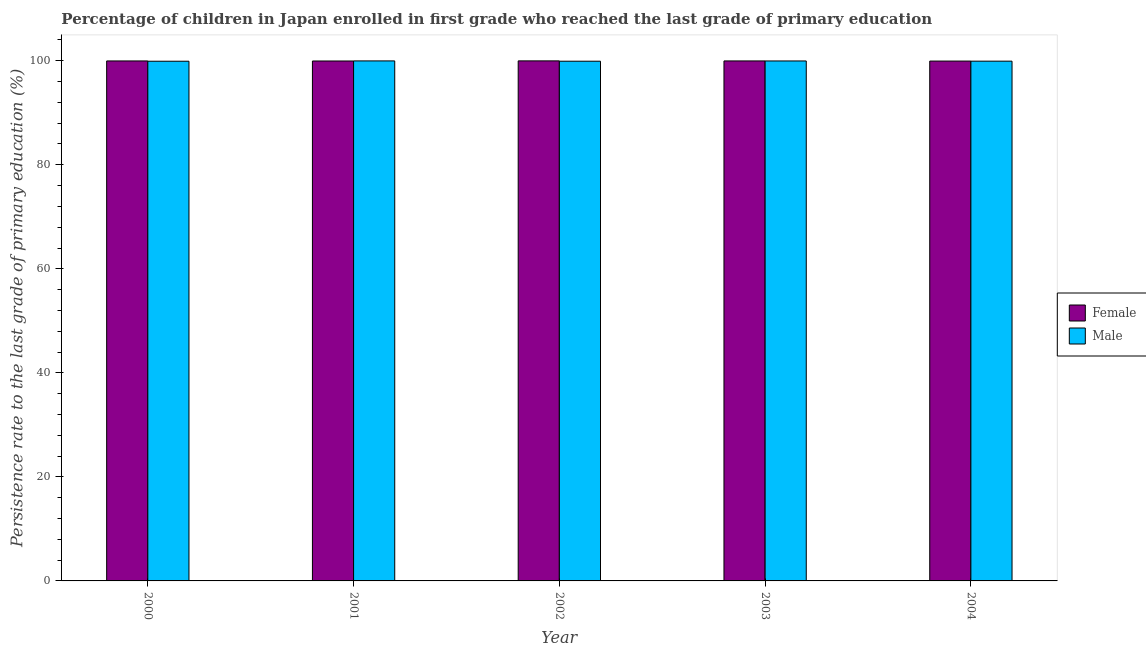How many different coloured bars are there?
Provide a short and direct response. 2. How many groups of bars are there?
Offer a very short reply. 5. Are the number of bars on each tick of the X-axis equal?
Your answer should be compact. Yes. How many bars are there on the 2nd tick from the left?
Keep it short and to the point. 2. What is the label of the 1st group of bars from the left?
Your answer should be very brief. 2000. What is the persistence rate of female students in 2002?
Keep it short and to the point. 99.98. Across all years, what is the maximum persistence rate of female students?
Your response must be concise. 99.98. Across all years, what is the minimum persistence rate of female students?
Ensure brevity in your answer.  99.94. In which year was the persistence rate of male students maximum?
Offer a terse response. 2001. In which year was the persistence rate of male students minimum?
Give a very brief answer. 2000. What is the total persistence rate of male students in the graph?
Give a very brief answer. 499.69. What is the difference between the persistence rate of female students in 2003 and that in 2004?
Ensure brevity in your answer.  0.03. What is the difference between the persistence rate of male students in 2000 and the persistence rate of female students in 2002?
Your answer should be very brief. -0. What is the average persistence rate of male students per year?
Your response must be concise. 99.94. What is the ratio of the persistence rate of male students in 2001 to that in 2004?
Your answer should be very brief. 1. Is the persistence rate of female students in 2000 less than that in 2004?
Offer a very short reply. No. Is the difference between the persistence rate of male students in 2000 and 2001 greater than the difference between the persistence rate of female students in 2000 and 2001?
Keep it short and to the point. No. What is the difference between the highest and the second highest persistence rate of male students?
Your response must be concise. 0.01. What is the difference between the highest and the lowest persistence rate of female students?
Offer a terse response. 0.04. In how many years, is the persistence rate of female students greater than the average persistence rate of female students taken over all years?
Offer a terse response. 3. Are all the bars in the graph horizontal?
Keep it short and to the point. No. Are the values on the major ticks of Y-axis written in scientific E-notation?
Keep it short and to the point. No. What is the title of the graph?
Give a very brief answer. Percentage of children in Japan enrolled in first grade who reached the last grade of primary education. Does "From Government" appear as one of the legend labels in the graph?
Your response must be concise. No. What is the label or title of the X-axis?
Give a very brief answer. Year. What is the label or title of the Y-axis?
Make the answer very short. Persistence rate to the last grade of primary education (%). What is the Persistence rate to the last grade of primary education (%) in Female in 2000?
Offer a terse response. 99.97. What is the Persistence rate to the last grade of primary education (%) in Male in 2000?
Your answer should be very brief. 99.91. What is the Persistence rate to the last grade of primary education (%) of Female in 2001?
Make the answer very short. 99.96. What is the Persistence rate to the last grade of primary education (%) in Male in 2001?
Your answer should be compact. 99.97. What is the Persistence rate to the last grade of primary education (%) of Female in 2002?
Offer a terse response. 99.98. What is the Persistence rate to the last grade of primary education (%) of Male in 2002?
Offer a terse response. 99.91. What is the Persistence rate to the last grade of primary education (%) of Female in 2003?
Offer a terse response. 99.97. What is the Persistence rate to the last grade of primary education (%) of Male in 2003?
Your response must be concise. 99.96. What is the Persistence rate to the last grade of primary education (%) in Female in 2004?
Your answer should be compact. 99.94. What is the Persistence rate to the last grade of primary education (%) of Male in 2004?
Keep it short and to the point. 99.92. Across all years, what is the maximum Persistence rate to the last grade of primary education (%) of Female?
Offer a terse response. 99.98. Across all years, what is the maximum Persistence rate to the last grade of primary education (%) in Male?
Give a very brief answer. 99.97. Across all years, what is the minimum Persistence rate to the last grade of primary education (%) in Female?
Your answer should be compact. 99.94. Across all years, what is the minimum Persistence rate to the last grade of primary education (%) of Male?
Your response must be concise. 99.91. What is the total Persistence rate to the last grade of primary education (%) in Female in the graph?
Your response must be concise. 499.82. What is the total Persistence rate to the last grade of primary education (%) of Male in the graph?
Your response must be concise. 499.69. What is the difference between the Persistence rate to the last grade of primary education (%) of Female in 2000 and that in 2001?
Your answer should be very brief. 0.01. What is the difference between the Persistence rate to the last grade of primary education (%) in Male in 2000 and that in 2001?
Provide a succinct answer. -0.06. What is the difference between the Persistence rate to the last grade of primary education (%) in Female in 2000 and that in 2002?
Make the answer very short. -0.01. What is the difference between the Persistence rate to the last grade of primary education (%) in Male in 2000 and that in 2002?
Your response must be concise. -0. What is the difference between the Persistence rate to the last grade of primary education (%) in Female in 2000 and that in 2003?
Ensure brevity in your answer.  -0. What is the difference between the Persistence rate to the last grade of primary education (%) in Male in 2000 and that in 2003?
Your response must be concise. -0.05. What is the difference between the Persistence rate to the last grade of primary education (%) of Female in 2000 and that in 2004?
Ensure brevity in your answer.  0.03. What is the difference between the Persistence rate to the last grade of primary education (%) of Male in 2000 and that in 2004?
Your answer should be compact. -0.01. What is the difference between the Persistence rate to the last grade of primary education (%) in Female in 2001 and that in 2002?
Offer a terse response. -0.02. What is the difference between the Persistence rate to the last grade of primary education (%) in Male in 2001 and that in 2002?
Give a very brief answer. 0.06. What is the difference between the Persistence rate to the last grade of primary education (%) of Female in 2001 and that in 2003?
Provide a short and direct response. -0.01. What is the difference between the Persistence rate to the last grade of primary education (%) in Male in 2001 and that in 2003?
Your response must be concise. 0.01. What is the difference between the Persistence rate to the last grade of primary education (%) in Female in 2001 and that in 2004?
Offer a terse response. 0.01. What is the difference between the Persistence rate to the last grade of primary education (%) of Male in 2001 and that in 2004?
Offer a terse response. 0.05. What is the difference between the Persistence rate to the last grade of primary education (%) of Female in 2002 and that in 2003?
Offer a very short reply. 0.01. What is the difference between the Persistence rate to the last grade of primary education (%) in Male in 2002 and that in 2003?
Ensure brevity in your answer.  -0.05. What is the difference between the Persistence rate to the last grade of primary education (%) in Female in 2002 and that in 2004?
Offer a very short reply. 0.04. What is the difference between the Persistence rate to the last grade of primary education (%) of Male in 2002 and that in 2004?
Offer a very short reply. -0.01. What is the difference between the Persistence rate to the last grade of primary education (%) in Female in 2003 and that in 2004?
Provide a short and direct response. 0.03. What is the difference between the Persistence rate to the last grade of primary education (%) of Male in 2003 and that in 2004?
Keep it short and to the point. 0.04. What is the difference between the Persistence rate to the last grade of primary education (%) in Female in 2000 and the Persistence rate to the last grade of primary education (%) in Male in 2001?
Offer a very short reply. -0.01. What is the difference between the Persistence rate to the last grade of primary education (%) of Female in 2000 and the Persistence rate to the last grade of primary education (%) of Male in 2002?
Ensure brevity in your answer.  0.05. What is the difference between the Persistence rate to the last grade of primary education (%) in Female in 2000 and the Persistence rate to the last grade of primary education (%) in Male in 2003?
Ensure brevity in your answer.  0.01. What is the difference between the Persistence rate to the last grade of primary education (%) of Female in 2000 and the Persistence rate to the last grade of primary education (%) of Male in 2004?
Make the answer very short. 0.04. What is the difference between the Persistence rate to the last grade of primary education (%) of Female in 2001 and the Persistence rate to the last grade of primary education (%) of Male in 2002?
Provide a succinct answer. 0.04. What is the difference between the Persistence rate to the last grade of primary education (%) of Female in 2001 and the Persistence rate to the last grade of primary education (%) of Male in 2003?
Your answer should be very brief. -0.01. What is the difference between the Persistence rate to the last grade of primary education (%) of Female in 2001 and the Persistence rate to the last grade of primary education (%) of Male in 2004?
Offer a very short reply. 0.03. What is the difference between the Persistence rate to the last grade of primary education (%) of Female in 2002 and the Persistence rate to the last grade of primary education (%) of Male in 2003?
Give a very brief answer. 0.02. What is the difference between the Persistence rate to the last grade of primary education (%) of Female in 2002 and the Persistence rate to the last grade of primary education (%) of Male in 2004?
Give a very brief answer. 0.06. What is the difference between the Persistence rate to the last grade of primary education (%) in Female in 2003 and the Persistence rate to the last grade of primary education (%) in Male in 2004?
Offer a very short reply. 0.05. What is the average Persistence rate to the last grade of primary education (%) in Female per year?
Give a very brief answer. 99.96. What is the average Persistence rate to the last grade of primary education (%) of Male per year?
Your answer should be very brief. 99.94. In the year 2000, what is the difference between the Persistence rate to the last grade of primary education (%) in Female and Persistence rate to the last grade of primary education (%) in Male?
Offer a terse response. 0.05. In the year 2001, what is the difference between the Persistence rate to the last grade of primary education (%) of Female and Persistence rate to the last grade of primary education (%) of Male?
Make the answer very short. -0.02. In the year 2002, what is the difference between the Persistence rate to the last grade of primary education (%) of Female and Persistence rate to the last grade of primary education (%) of Male?
Provide a succinct answer. 0.07. In the year 2003, what is the difference between the Persistence rate to the last grade of primary education (%) in Female and Persistence rate to the last grade of primary education (%) in Male?
Make the answer very short. 0.01. In the year 2004, what is the difference between the Persistence rate to the last grade of primary education (%) in Female and Persistence rate to the last grade of primary education (%) in Male?
Make the answer very short. 0.02. What is the ratio of the Persistence rate to the last grade of primary education (%) in Male in 2000 to that in 2002?
Offer a terse response. 1. What is the ratio of the Persistence rate to the last grade of primary education (%) in Male in 2000 to that in 2003?
Provide a short and direct response. 1. What is the ratio of the Persistence rate to the last grade of primary education (%) of Male in 2000 to that in 2004?
Make the answer very short. 1. What is the ratio of the Persistence rate to the last grade of primary education (%) in Male in 2001 to that in 2003?
Ensure brevity in your answer.  1. What is the ratio of the Persistence rate to the last grade of primary education (%) of Female in 2001 to that in 2004?
Your answer should be very brief. 1. What is the ratio of the Persistence rate to the last grade of primary education (%) in Male in 2001 to that in 2004?
Make the answer very short. 1. What is the ratio of the Persistence rate to the last grade of primary education (%) in Female in 2002 to that in 2004?
Offer a very short reply. 1. What is the ratio of the Persistence rate to the last grade of primary education (%) in Female in 2003 to that in 2004?
Your answer should be compact. 1. What is the difference between the highest and the second highest Persistence rate to the last grade of primary education (%) in Female?
Offer a terse response. 0.01. What is the difference between the highest and the second highest Persistence rate to the last grade of primary education (%) in Male?
Offer a very short reply. 0.01. What is the difference between the highest and the lowest Persistence rate to the last grade of primary education (%) in Female?
Keep it short and to the point. 0.04. What is the difference between the highest and the lowest Persistence rate to the last grade of primary education (%) of Male?
Ensure brevity in your answer.  0.06. 